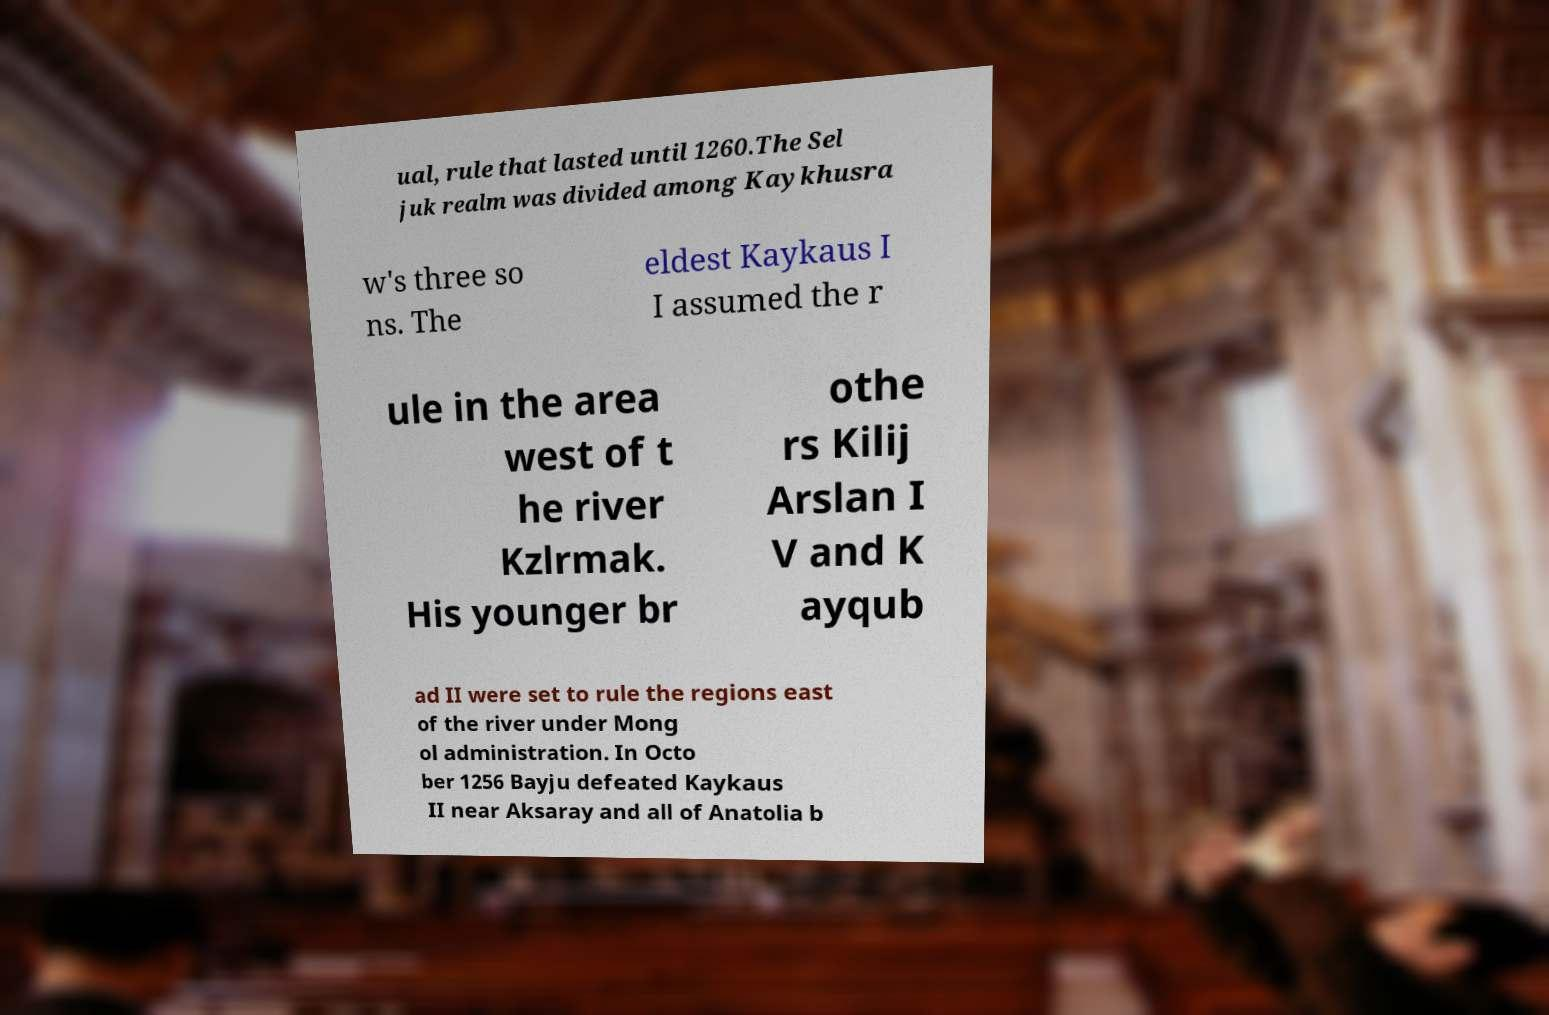Could you extract and type out the text from this image? ual, rule that lasted until 1260.The Sel juk realm was divided among Kaykhusra w's three so ns. The eldest Kaykaus I I assumed the r ule in the area west of t he river Kzlrmak. His younger br othe rs Kilij Arslan I V and K ayqub ad II were set to rule the regions east of the river under Mong ol administration. In Octo ber 1256 Bayju defeated Kaykaus II near Aksaray and all of Anatolia b 